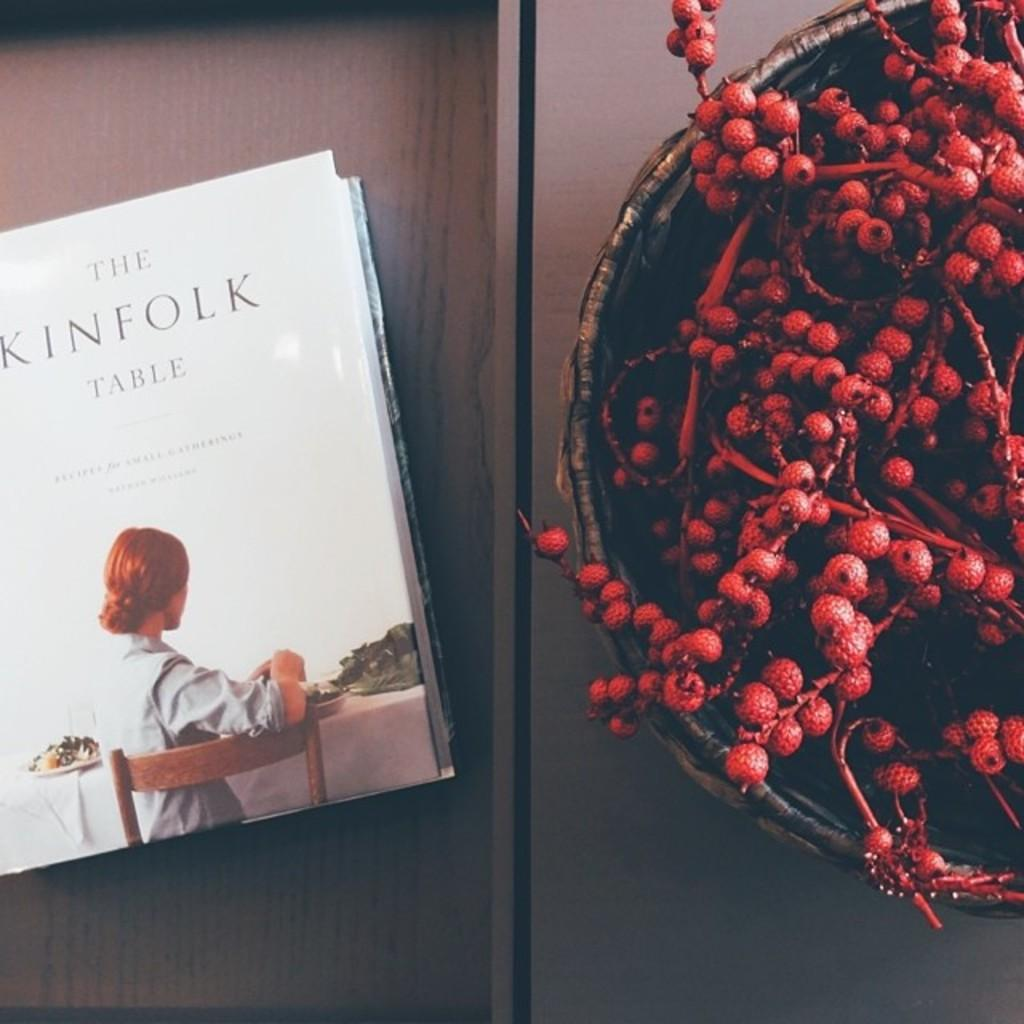<image>
Provide a brief description of the given image. A book called The Kinfolk Table sits next to a bowl of red berries. 